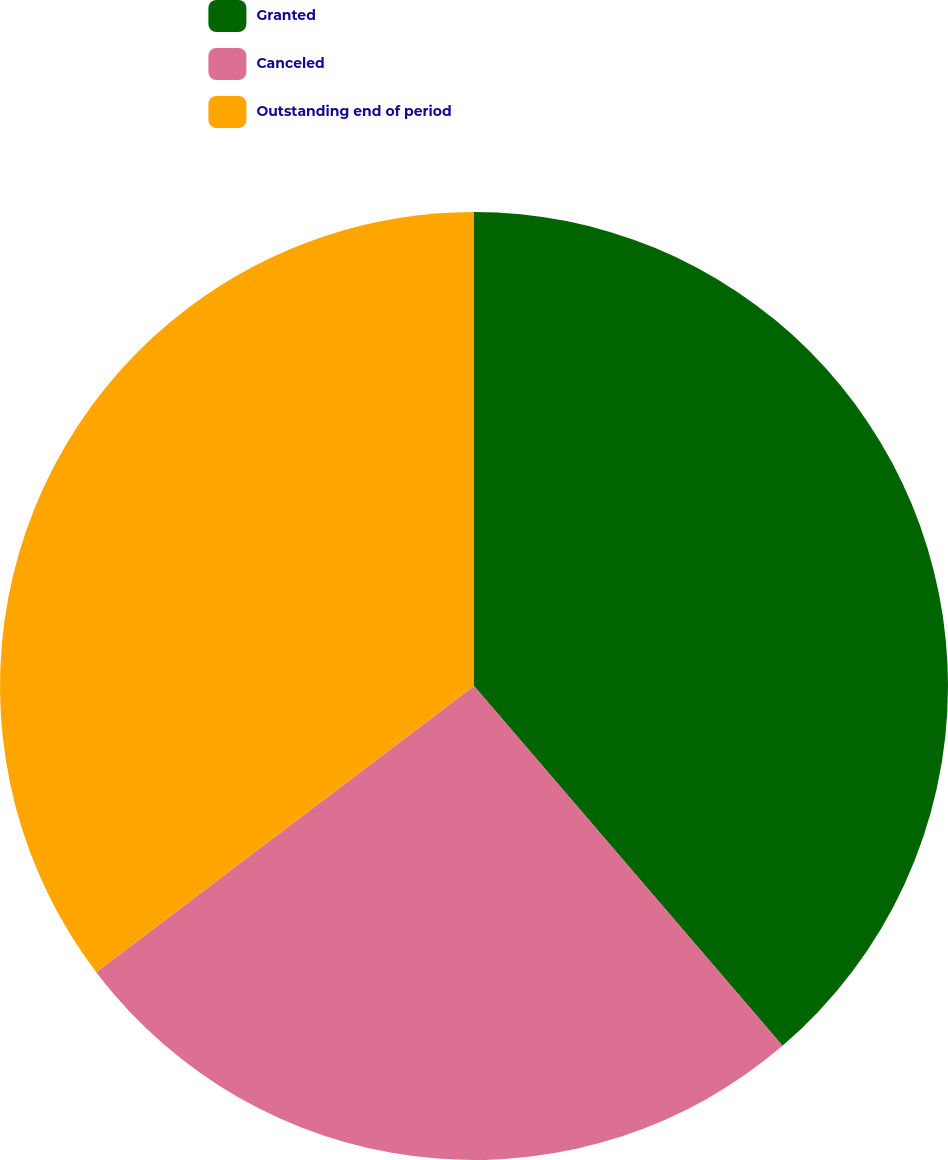Convert chart. <chart><loc_0><loc_0><loc_500><loc_500><pie_chart><fcel>Granted<fcel>Canceled<fcel>Outstanding end of period<nl><fcel>38.72%<fcel>25.96%<fcel>35.32%<nl></chart> 